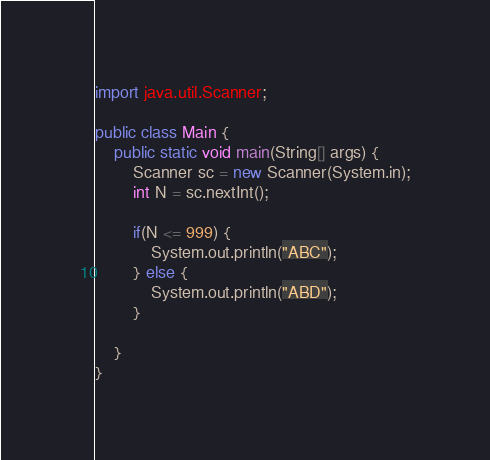Convert code to text. <code><loc_0><loc_0><loc_500><loc_500><_Java_>import java.util.Scanner;

public class Main {
	public static void main(String[] args) {
		Scanner sc = new Scanner(System.in);
		int N = sc.nextInt();
		
		if(N <= 999) {
			System.out.println("ABC");
		} else {
			System.out.println("ABD");
		}
		
	}
}
</code> 